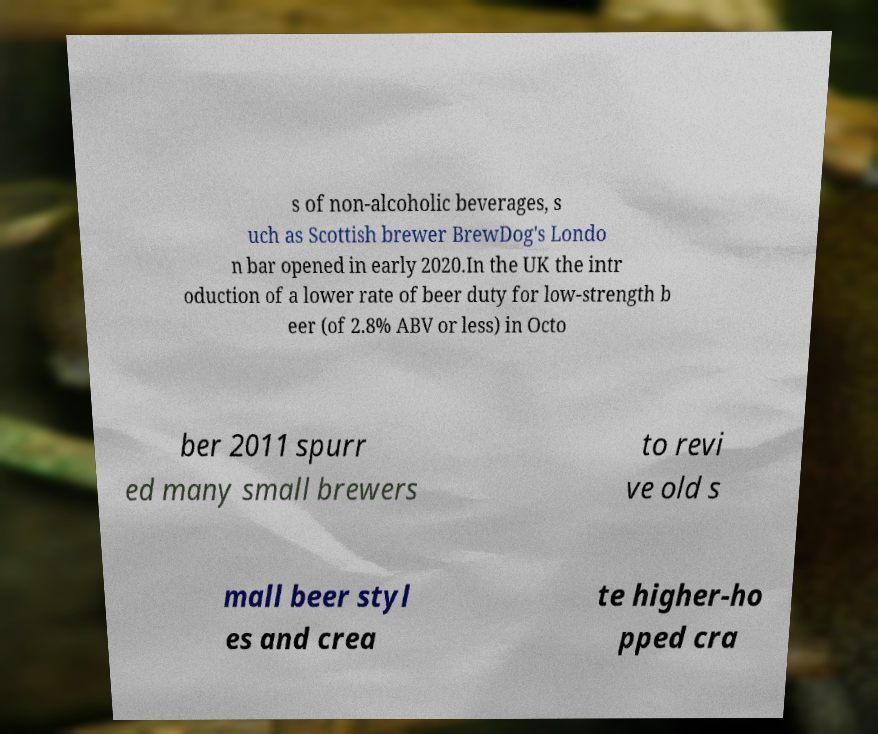Could you extract and type out the text from this image? s of non-alcoholic beverages, s uch as Scottish brewer BrewDog's Londo n bar opened in early 2020.In the UK the intr oduction of a lower rate of beer duty for low-strength b eer (of 2.8% ABV or less) in Octo ber 2011 spurr ed many small brewers to revi ve old s mall beer styl es and crea te higher-ho pped cra 